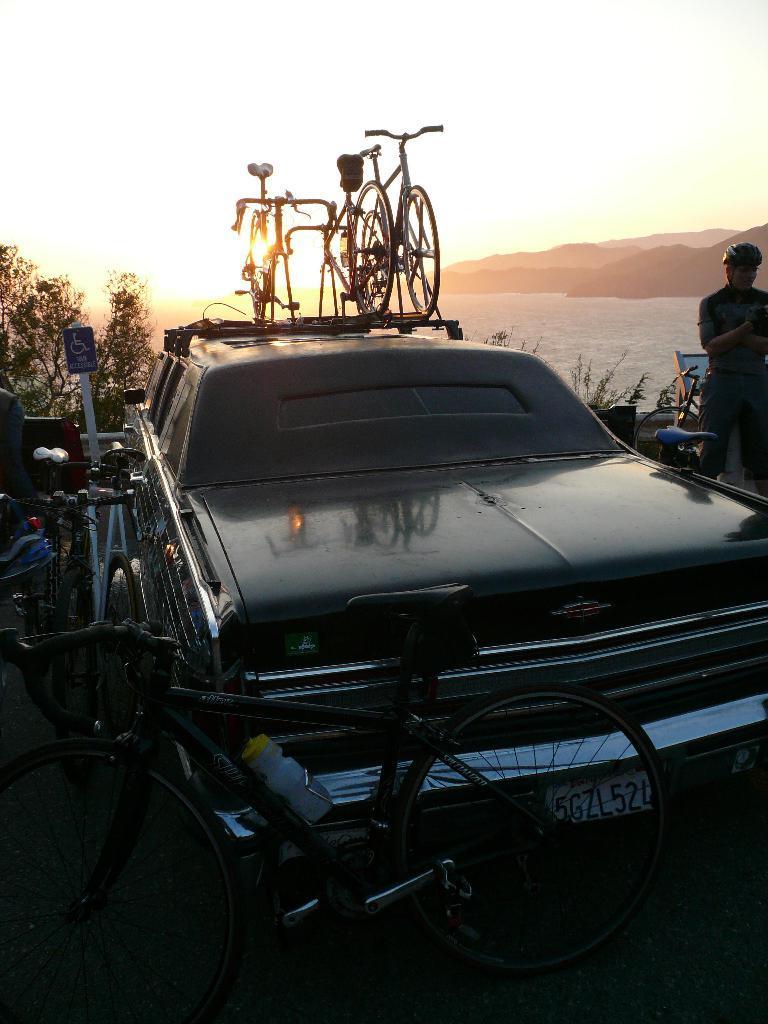Please provide a concise description of this image. In the image in the center we can see one vehicle. And we can see one sign board and few cycles and one person standing and wearing helmet. On the vehicle,we can see few cycles. In the background we can see the sky,hills,water and trees. 